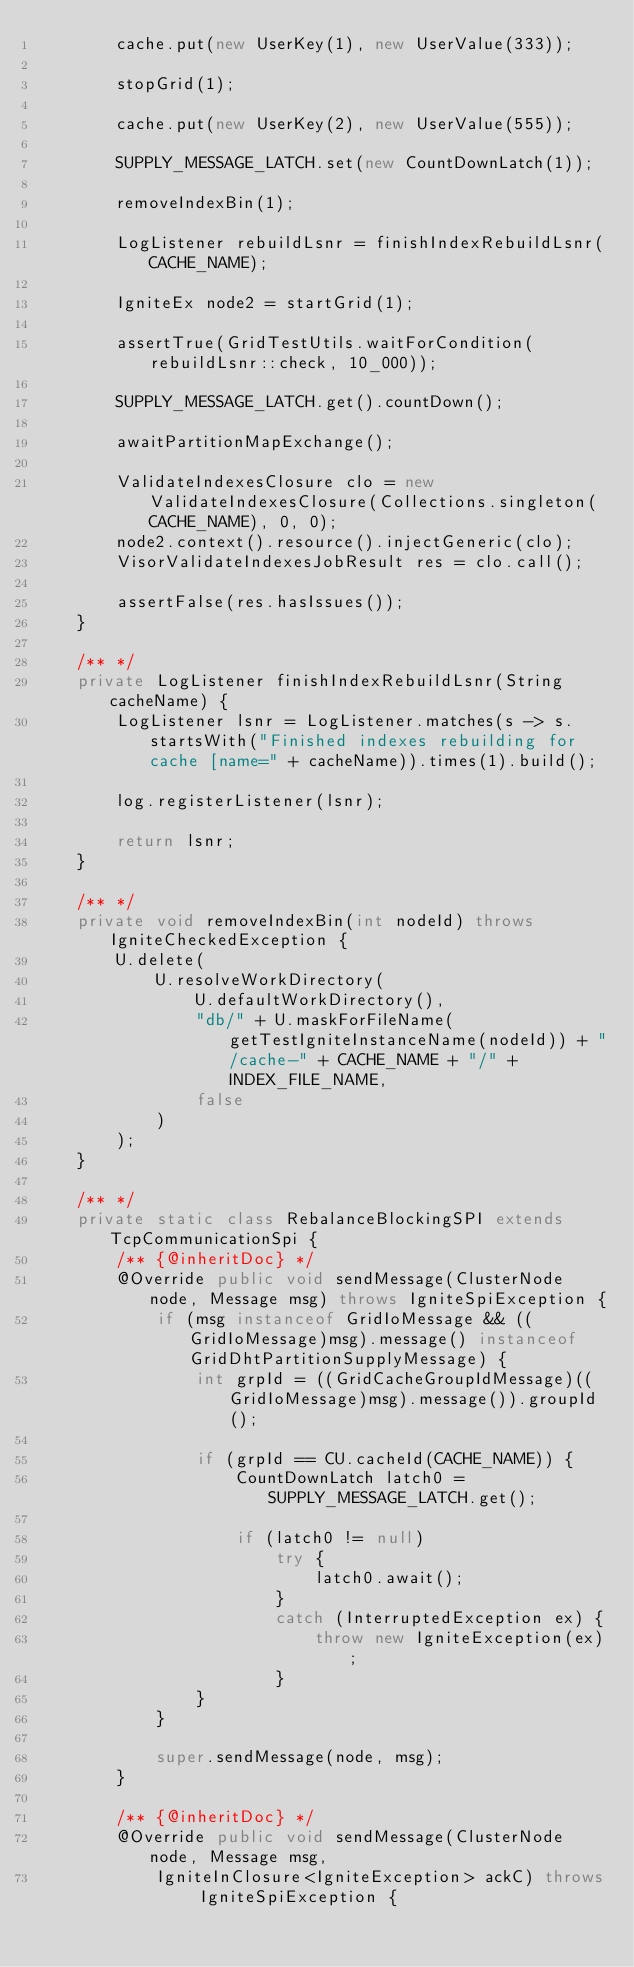Convert code to text. <code><loc_0><loc_0><loc_500><loc_500><_Java_>        cache.put(new UserKey(1), new UserValue(333));

        stopGrid(1);

        cache.put(new UserKey(2), new UserValue(555));

        SUPPLY_MESSAGE_LATCH.set(new CountDownLatch(1));

        removeIndexBin(1);

        LogListener rebuildLsnr = finishIndexRebuildLsnr(CACHE_NAME);

        IgniteEx node2 = startGrid(1);

        assertTrue(GridTestUtils.waitForCondition(rebuildLsnr::check, 10_000));

        SUPPLY_MESSAGE_LATCH.get().countDown();

        awaitPartitionMapExchange();

        ValidateIndexesClosure clo = new ValidateIndexesClosure(Collections.singleton(CACHE_NAME), 0, 0);
        node2.context().resource().injectGeneric(clo);
        VisorValidateIndexesJobResult res = clo.call();

        assertFalse(res.hasIssues());
    }

    /** */
    private LogListener finishIndexRebuildLsnr(String cacheName) {
        LogListener lsnr = LogListener.matches(s -> s.startsWith("Finished indexes rebuilding for cache [name=" + cacheName)).times(1).build();

        log.registerListener(lsnr);

        return lsnr;
    }

    /** */
    private void removeIndexBin(int nodeId) throws IgniteCheckedException {
        U.delete(
            U.resolveWorkDirectory(
                U.defaultWorkDirectory(),
                "db/" + U.maskForFileName(getTestIgniteInstanceName(nodeId)) + "/cache-" + CACHE_NAME + "/" + INDEX_FILE_NAME,
                false
            )
        );
    }

    /** */
    private static class RebalanceBlockingSPI extends TcpCommunicationSpi {
        /** {@inheritDoc} */
        @Override public void sendMessage(ClusterNode node, Message msg) throws IgniteSpiException {
            if (msg instanceof GridIoMessage && ((GridIoMessage)msg).message() instanceof GridDhtPartitionSupplyMessage) {
                int grpId = ((GridCacheGroupIdMessage)((GridIoMessage)msg).message()).groupId();

                if (grpId == CU.cacheId(CACHE_NAME)) {
                    CountDownLatch latch0 = SUPPLY_MESSAGE_LATCH.get();

                    if (latch0 != null)
                        try {
                            latch0.await();
                        }
                        catch (InterruptedException ex) {
                            throw new IgniteException(ex);
                        }
                }
            }

            super.sendMessage(node, msg);
        }

        /** {@inheritDoc} */
        @Override public void sendMessage(ClusterNode node, Message msg,
            IgniteInClosure<IgniteException> ackC) throws IgniteSpiException {</code> 